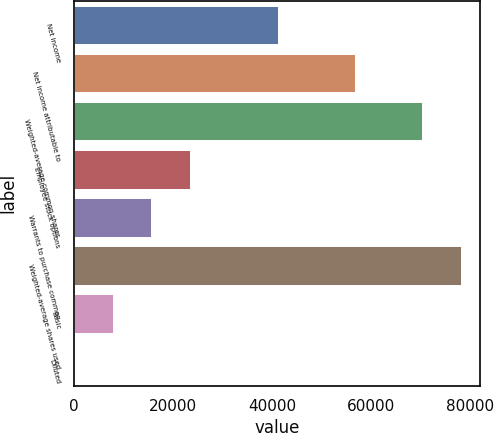Convert chart. <chart><loc_0><loc_0><loc_500><loc_500><bar_chart><fcel>Net income<fcel>Net income attributable to<fcel>Weighted-average common shares<fcel>Employee stock options<fcel>Warrants to purchase common<fcel>Weighted-average shares used<fcel>Basic<fcel>Diluted<nl><fcel>41245<fcel>56885.5<fcel>70363<fcel>23461.3<fcel>15641<fcel>78203<fcel>7820.78<fcel>0.53<nl></chart> 